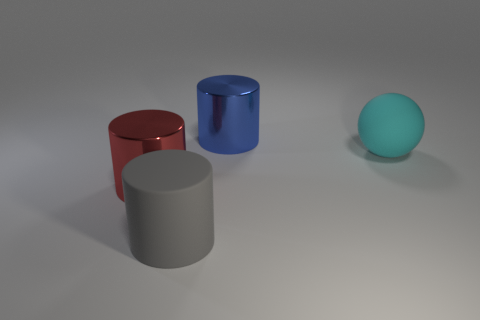Are there an equal number of blue cylinders that are on the right side of the big cyan matte ball and objects that are on the right side of the blue shiny cylinder?
Ensure brevity in your answer.  No. Does the thing that is behind the ball have the same shape as the rubber object on the left side of the large blue cylinder?
Offer a terse response. Yes. Are there any other things that have the same shape as the cyan thing?
Your response must be concise. No. What shape is the big object that is the same material as the ball?
Your answer should be compact. Cylinder. Are there an equal number of big red objects behind the matte sphere and tiny purple metallic balls?
Your answer should be very brief. Yes. Do the large object that is behind the cyan sphere and the large red cylinder to the left of the large blue metallic cylinder have the same material?
Your answer should be compact. Yes. The rubber object left of the large thing that is behind the big cyan rubber sphere is what shape?
Ensure brevity in your answer.  Cylinder. There is a big cylinder that is the same material as the blue object; what is its color?
Your answer should be compact. Red. What shape is the rubber thing that is the same size as the gray rubber cylinder?
Offer a very short reply. Sphere. What size is the red cylinder?
Ensure brevity in your answer.  Large. 